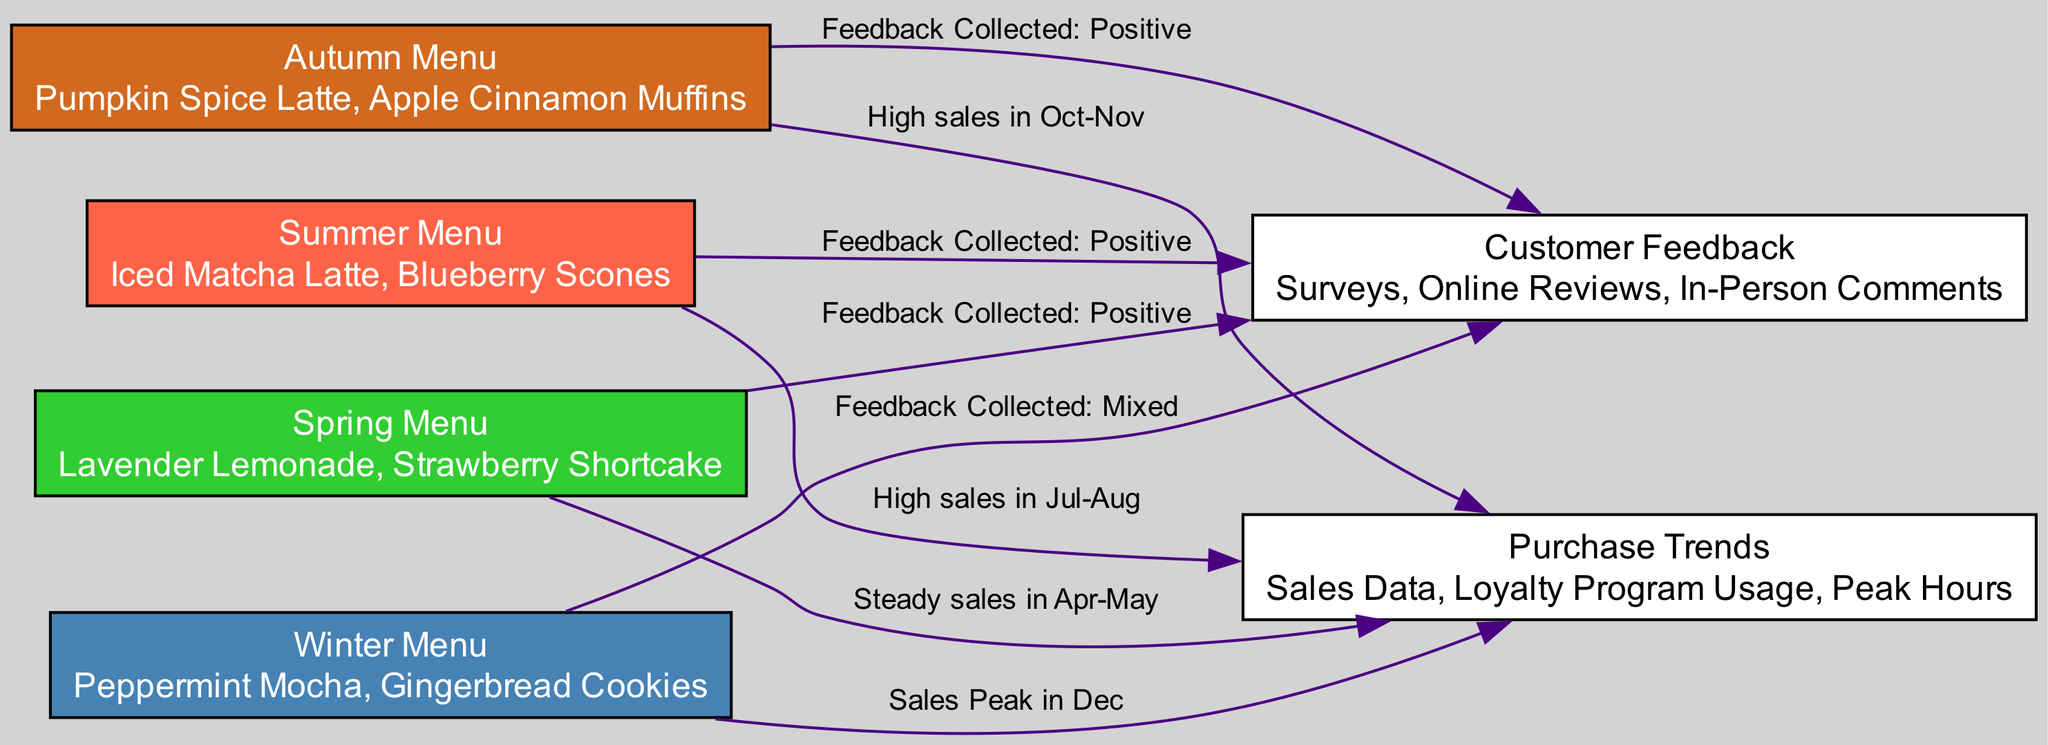What seasonal menu items are included in the Autumn Menu? The Autumn Menu includes "Pumpkin Spice Latte" and "Apple Cinnamon Muffins." This information can be directly found in the description of the Autumn Menu node in the diagram.
Answer: Pumpkin Spice Latte, Apple Cinnamon Muffins What type of feedback was collected from the Winter Menu? The feedback collected from the Winter Menu is described as "Mixed." This can be seen in the edge that connects the Winter Menu node to the Customer Feedback node.
Answer: Mixed How many nodes are present in the diagram? The diagram consists of six nodes, which include the four seasonal menus, customer feedback, and purchase trends. This can be determined by counting the specific nodes listed in the diagram.
Answer: 6 What is the sales trend for the Summer Menu? The sales trend for the Summer Menu shows "High sales in Jul-Aug." This is indicated in the edge that connects the Summer Menu node to the Purchase Trends node.
Answer: High sales in Jul-Aug Which seasonal menu received positive feedback according to customer surveys? Both the Autumn Menu and Spring Menu received positive feedback, as indicated by their respective edges connecting to the Customer Feedback node, which state "Feedback Collected: Positive."
Answer: Autumn Menu, Spring Menu What is the purchase trend associated with the Autumn Menu? The purchase trend associated with the Autumn Menu shows "High sales in Oct-Nov." This information is found in the edge leading from the Autumn Menu to the Purchase Trends node.
Answer: High sales in Oct-Nov What is the peak sales month for the Winter Menu? The peak sales month for the Winter Menu is "December." This conclusion can be drawn from the edge that connects the Winter Menu node to the Purchase Trends node, which specifies "Sales Peak in Dec."
Answer: December Which menu had a steady sales period identified in the diagram? The Spring Menu had a steady sales period, as represented by the edge connecting the Spring Menu to the Purchase Trends node, stating "Steady sales in Apr-May."
Answer: Spring Menu 